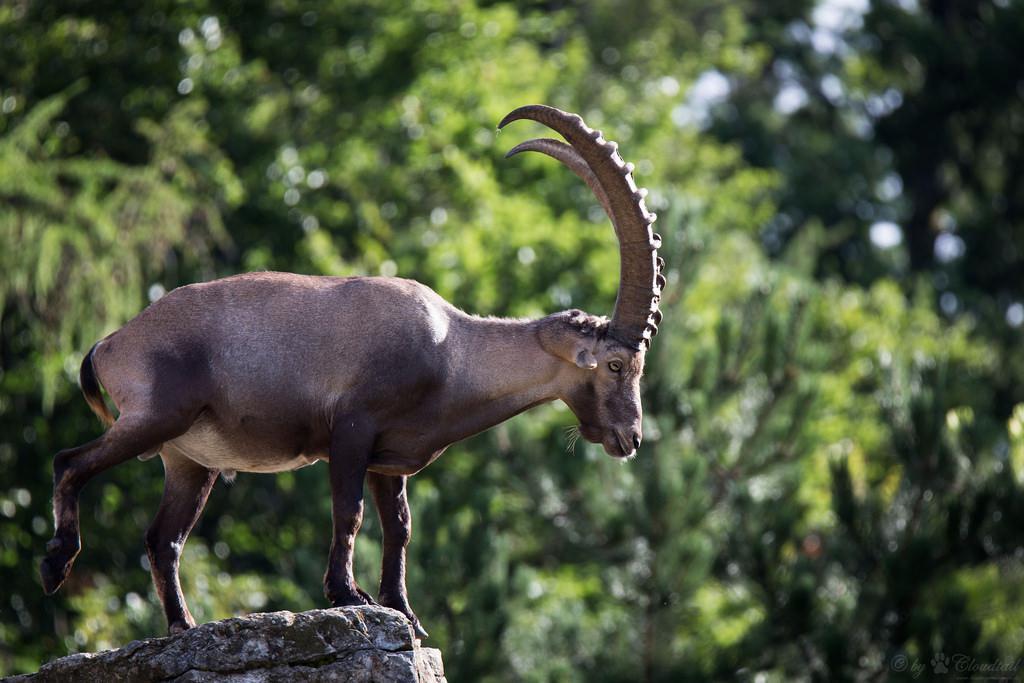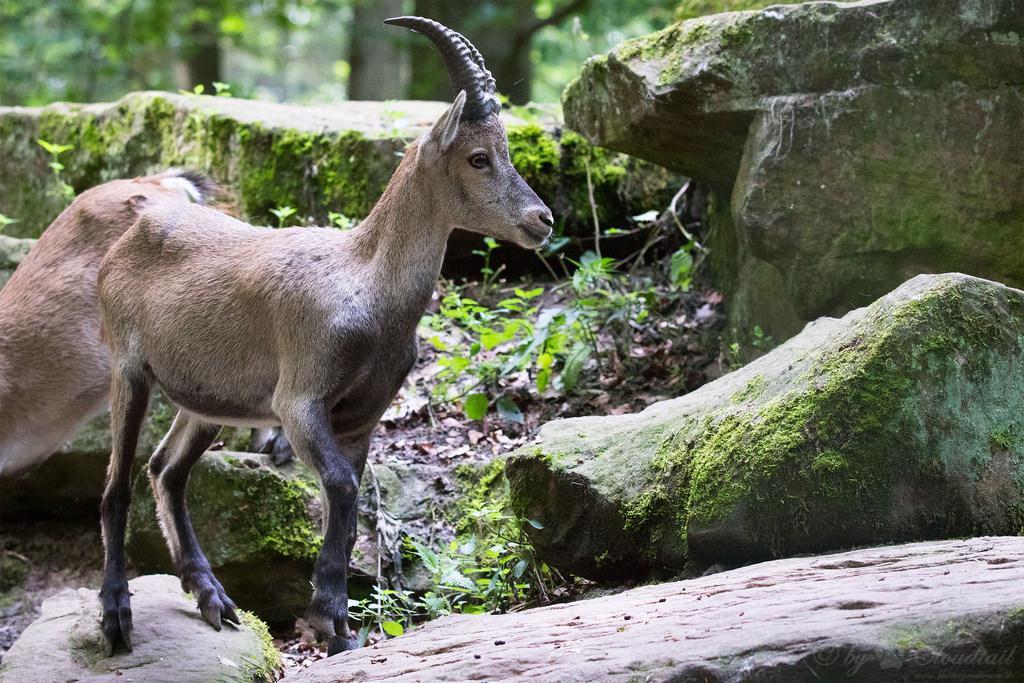The first image is the image on the left, the second image is the image on the right. Examine the images to the left and right. Is the description "One of the goats is on the ground, resting." accurate? Answer yes or no. No. 